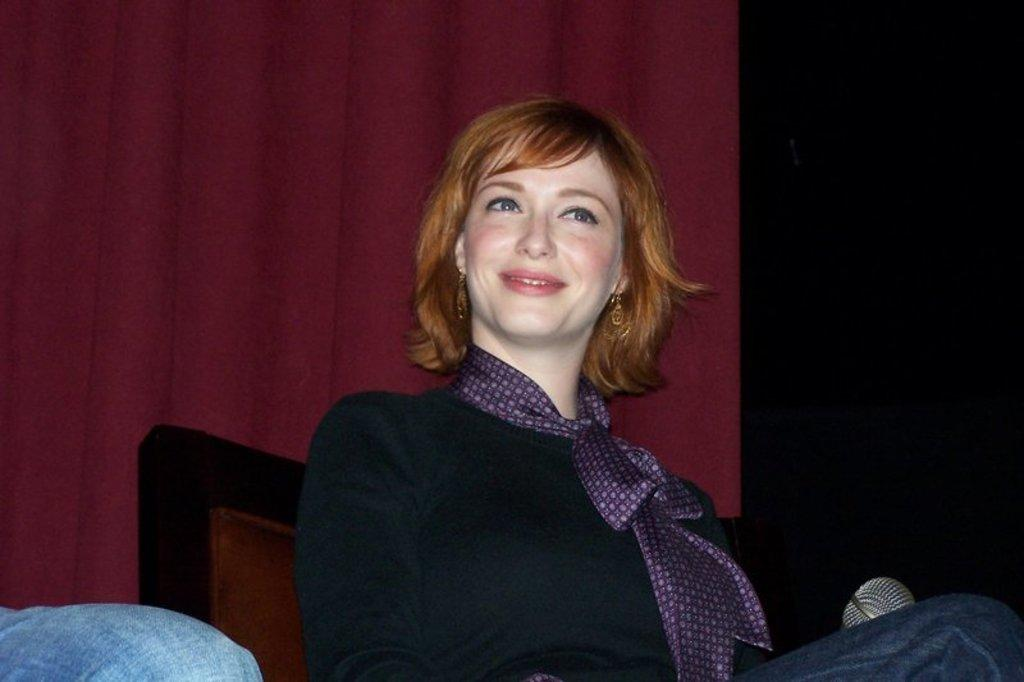Who is present in the image? There is a woman in the image. What is the woman doing in the image? The woman is sitting on a chair in the image. What object can be seen near the woman? There is a mic in the image. What can be seen in the background of the image? There is a curtain in the background of the image. Can you see the store receipt on the floor in the image? There is no store receipt present in the image. What type of powder is visible on the woman's face in the image? There is no powder visible on the woman's face in the image. 